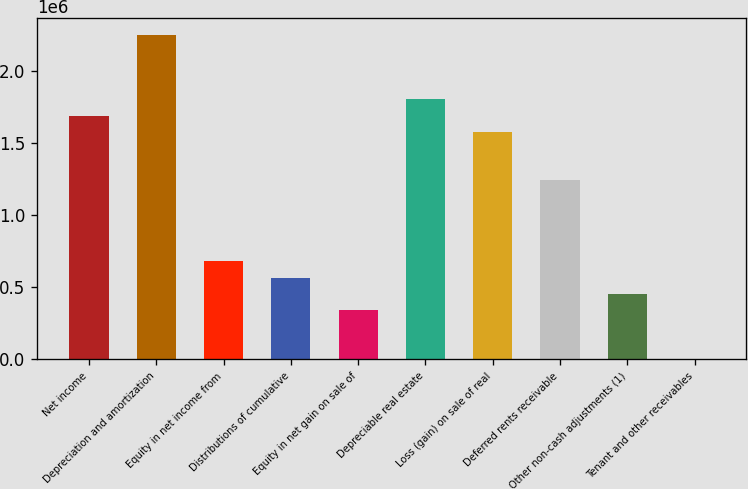Convert chart to OTSL. <chart><loc_0><loc_0><loc_500><loc_500><bar_chart><fcel>Net income<fcel>Depreciation and amortization<fcel>Equity in net income from<fcel>Distributions of cumulative<fcel>Equity in net gain on sale of<fcel>Depreciable real estate<fcel>Loss (gain) on sale of real<fcel>Deferred rents receivable<fcel>Other non-cash adjustments (1)<fcel>Tenant and other receivables<nl><fcel>1.6921e+06<fcel>2.25422e+06<fcel>680269<fcel>567844<fcel>342993<fcel>1.80452e+06<fcel>1.57967e+06<fcel>1.2424e+06<fcel>455418<fcel>5717<nl></chart> 